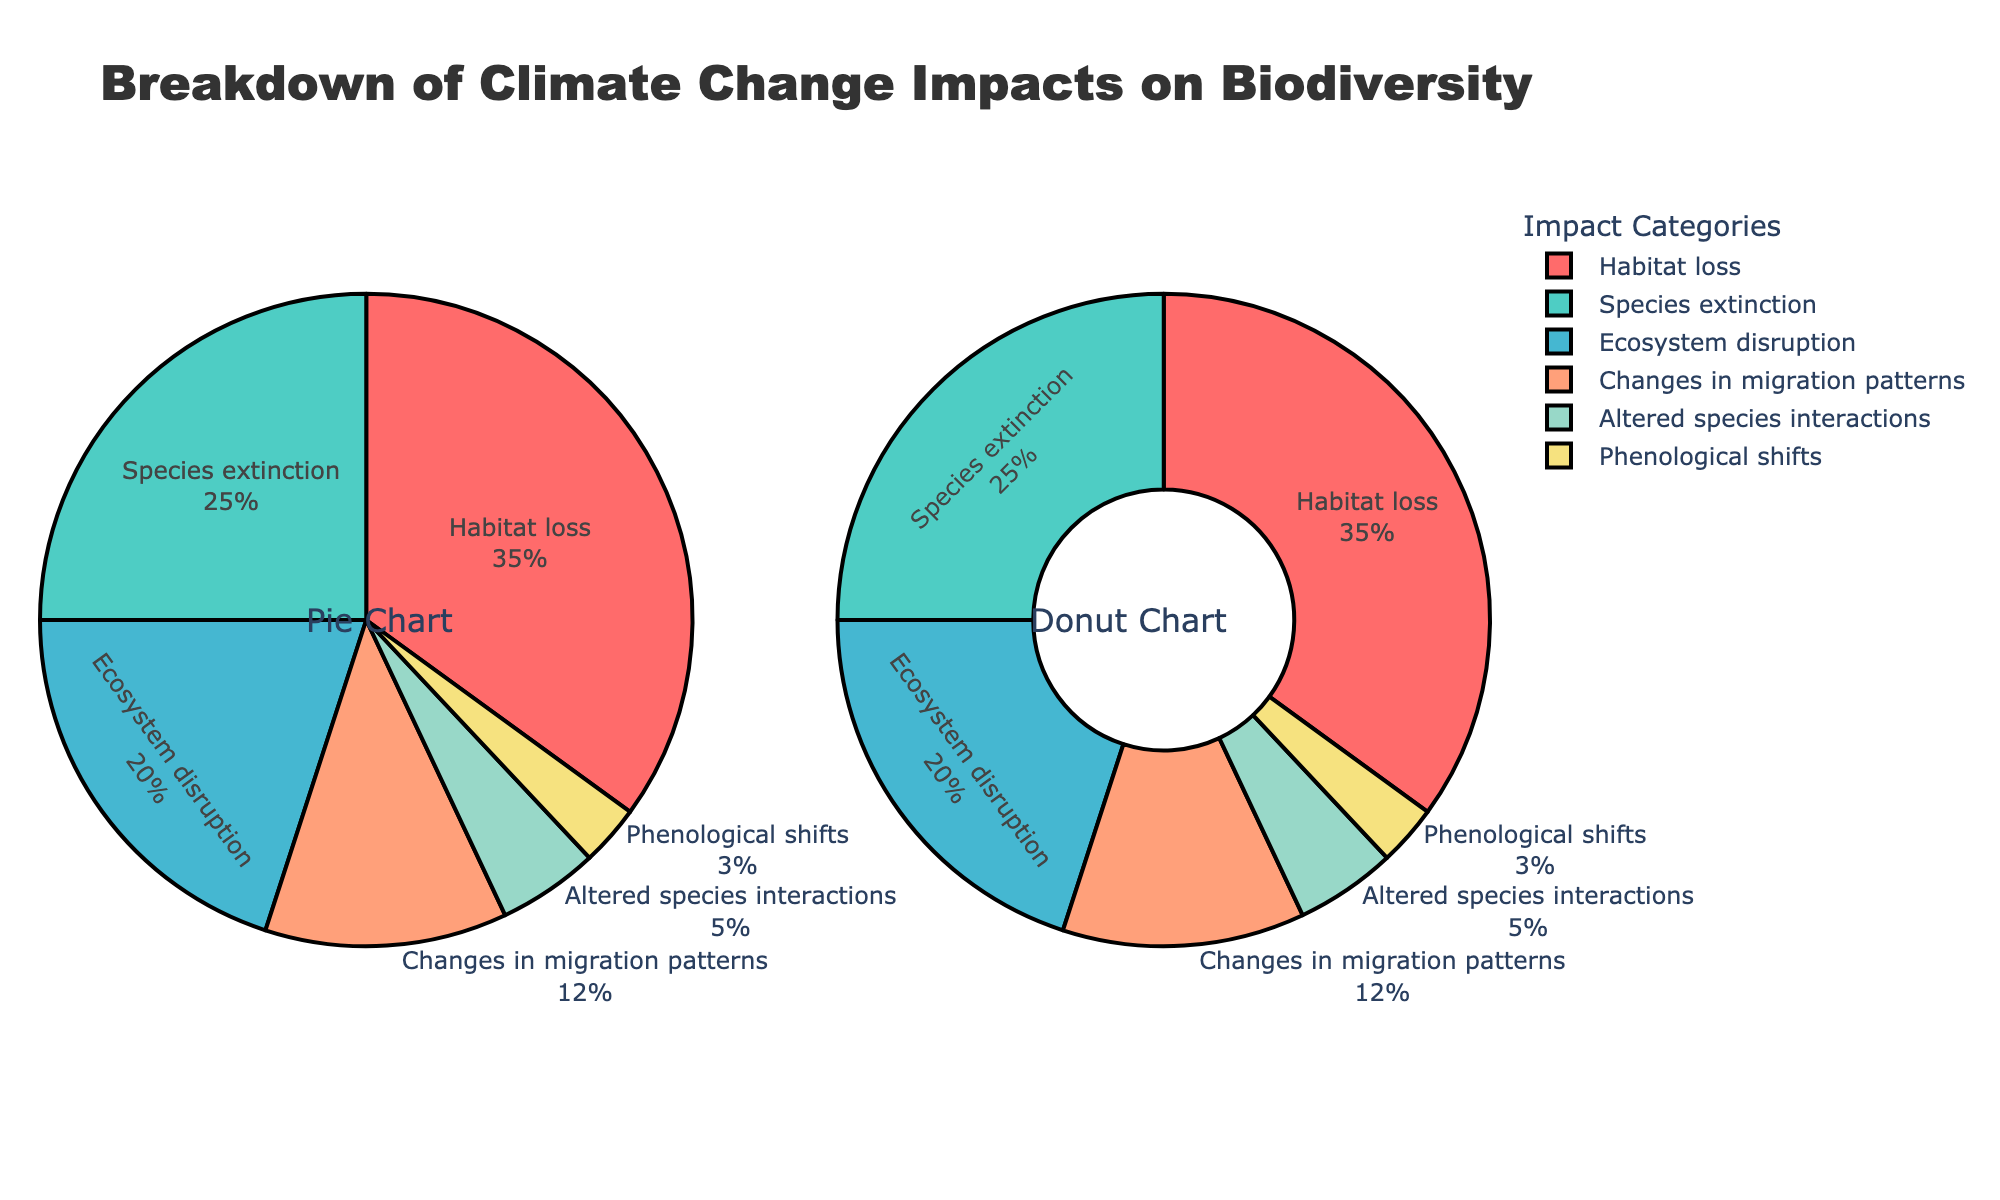What is the largest impact category on biodiversity due to climate change? The largest impact category is identified by its largest percentage value in the pie chart. Habitat loss has the highest value of 35%.
Answer: Habitat loss What is the combined percentage of species extinction and ecosystem disruption? To find the combined percentage, sum the values for species extinction (25%) and ecosystem disruption (20%). 25 + 20 = 45.
Answer: 45% Which impact category has the lowest percentage? The lowest percentage is obtained by identifying the smallest value in the chart, which is 3% for phenological shifts.
Answer: Phenological shifts How much more significant is habitat loss compared to changes in migration patterns? To find how much more significant habitat loss is compared to changes in migration patterns, subtract the percentage of changes in migration patterns (12%) from the percentage of habitat loss (35%). 35 - 12 = 23.
Answer: 23% What is the average percentage impact of altered species interactions and phenological shifts? To get the average, add the percentages for altered species interactions (5%) and phenological shifts (3%), then divide by 2. (5 + 3) / 2 = 4.
Answer: 4% Which impact categories together constitute exactly half of the total impact? Examine combinations of impact categories to see which sum to 50%. Habitat loss (35%) and changes in migration patterns (12%) together make 47%, so adding another 3% value (phenological shifts) fulfills the requirement. Thus, habitat loss + changes in migration patterns + phenological shifts = 50%.
Answer: Habitat loss, Changes in migration patterns, Phenological shifts How does the percentage of ecosystem disruption compare to altered species interactions? Compare the percentages directly, where ecosystem disruption is 20% and altered species interactions is 5%. 20% is greater than 5%.
Answer: Ecosystem disruption > Altered species interactions What is the total percentage of impact for all categories which have a percentage lower than 10%? Identify categories with a percentage less than 10% (altered species interactions - 5%, phenological shifts - 3%). Sum these values: 5 + 3 = 8.
Answer: 8% What color is associated with species extinction in the pie chart? The color associated with species extinction is identified visually from the chart, which is shaded in a specific color— turquoise.
Answer: Turquoise 